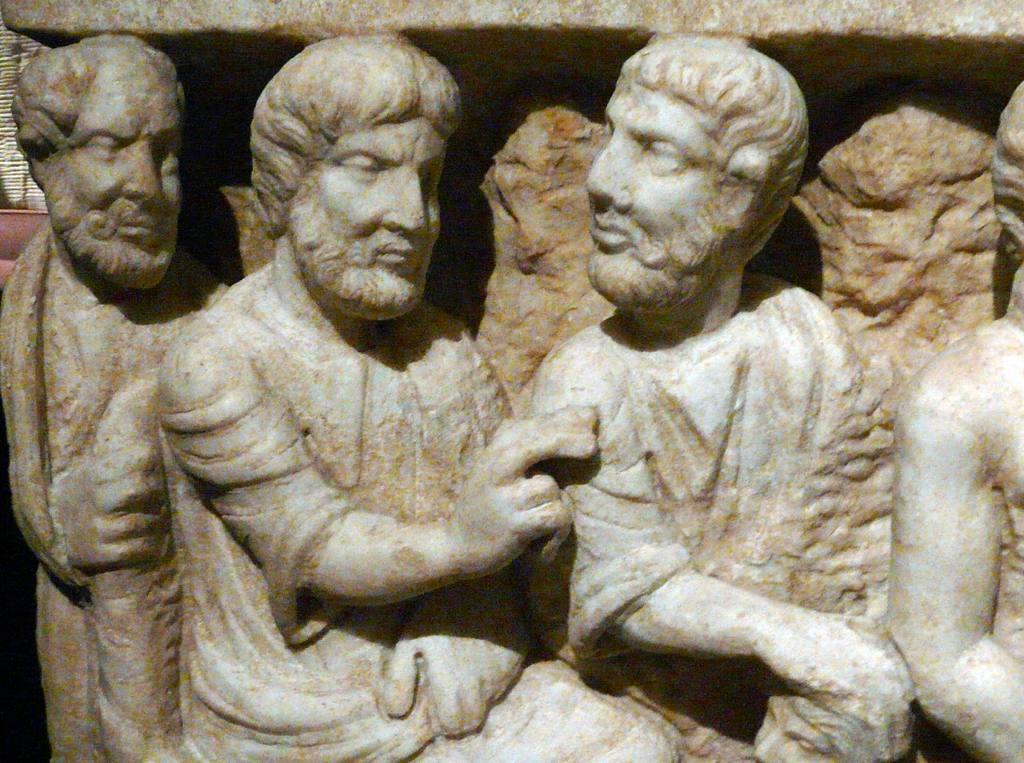Can you describe this image briefly? In this image I can see sculptures of persons. 